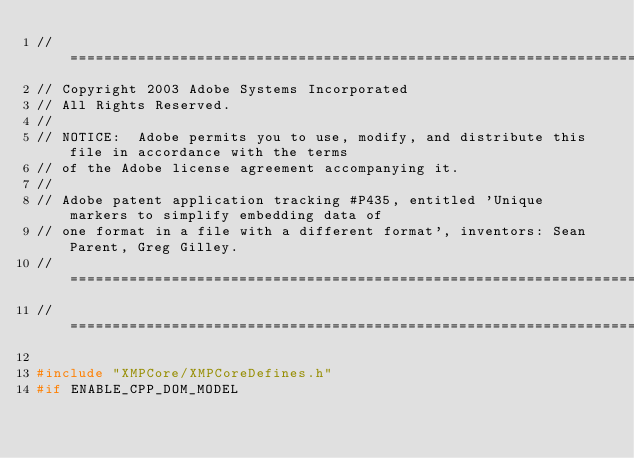<code> <loc_0><loc_0><loc_500><loc_500><_C++_>// =================================================================================================
// Copyright 2003 Adobe Systems Incorporated
// All Rights Reserved.
//
// NOTICE:  Adobe permits you to use, modify, and distribute this file in accordance with the terms
// of the Adobe license agreement accompanying it.
//
// Adobe patent application tracking #P435, entitled 'Unique markers to simplify embedding data of
// one format in a file with a different format', inventors: Sean Parent, Greg Gilley.
// =================================================================================================
// =================================================================================================

#include "XMPCore/XMPCoreDefines.h"
#if ENABLE_CPP_DOM_MODEL</code> 